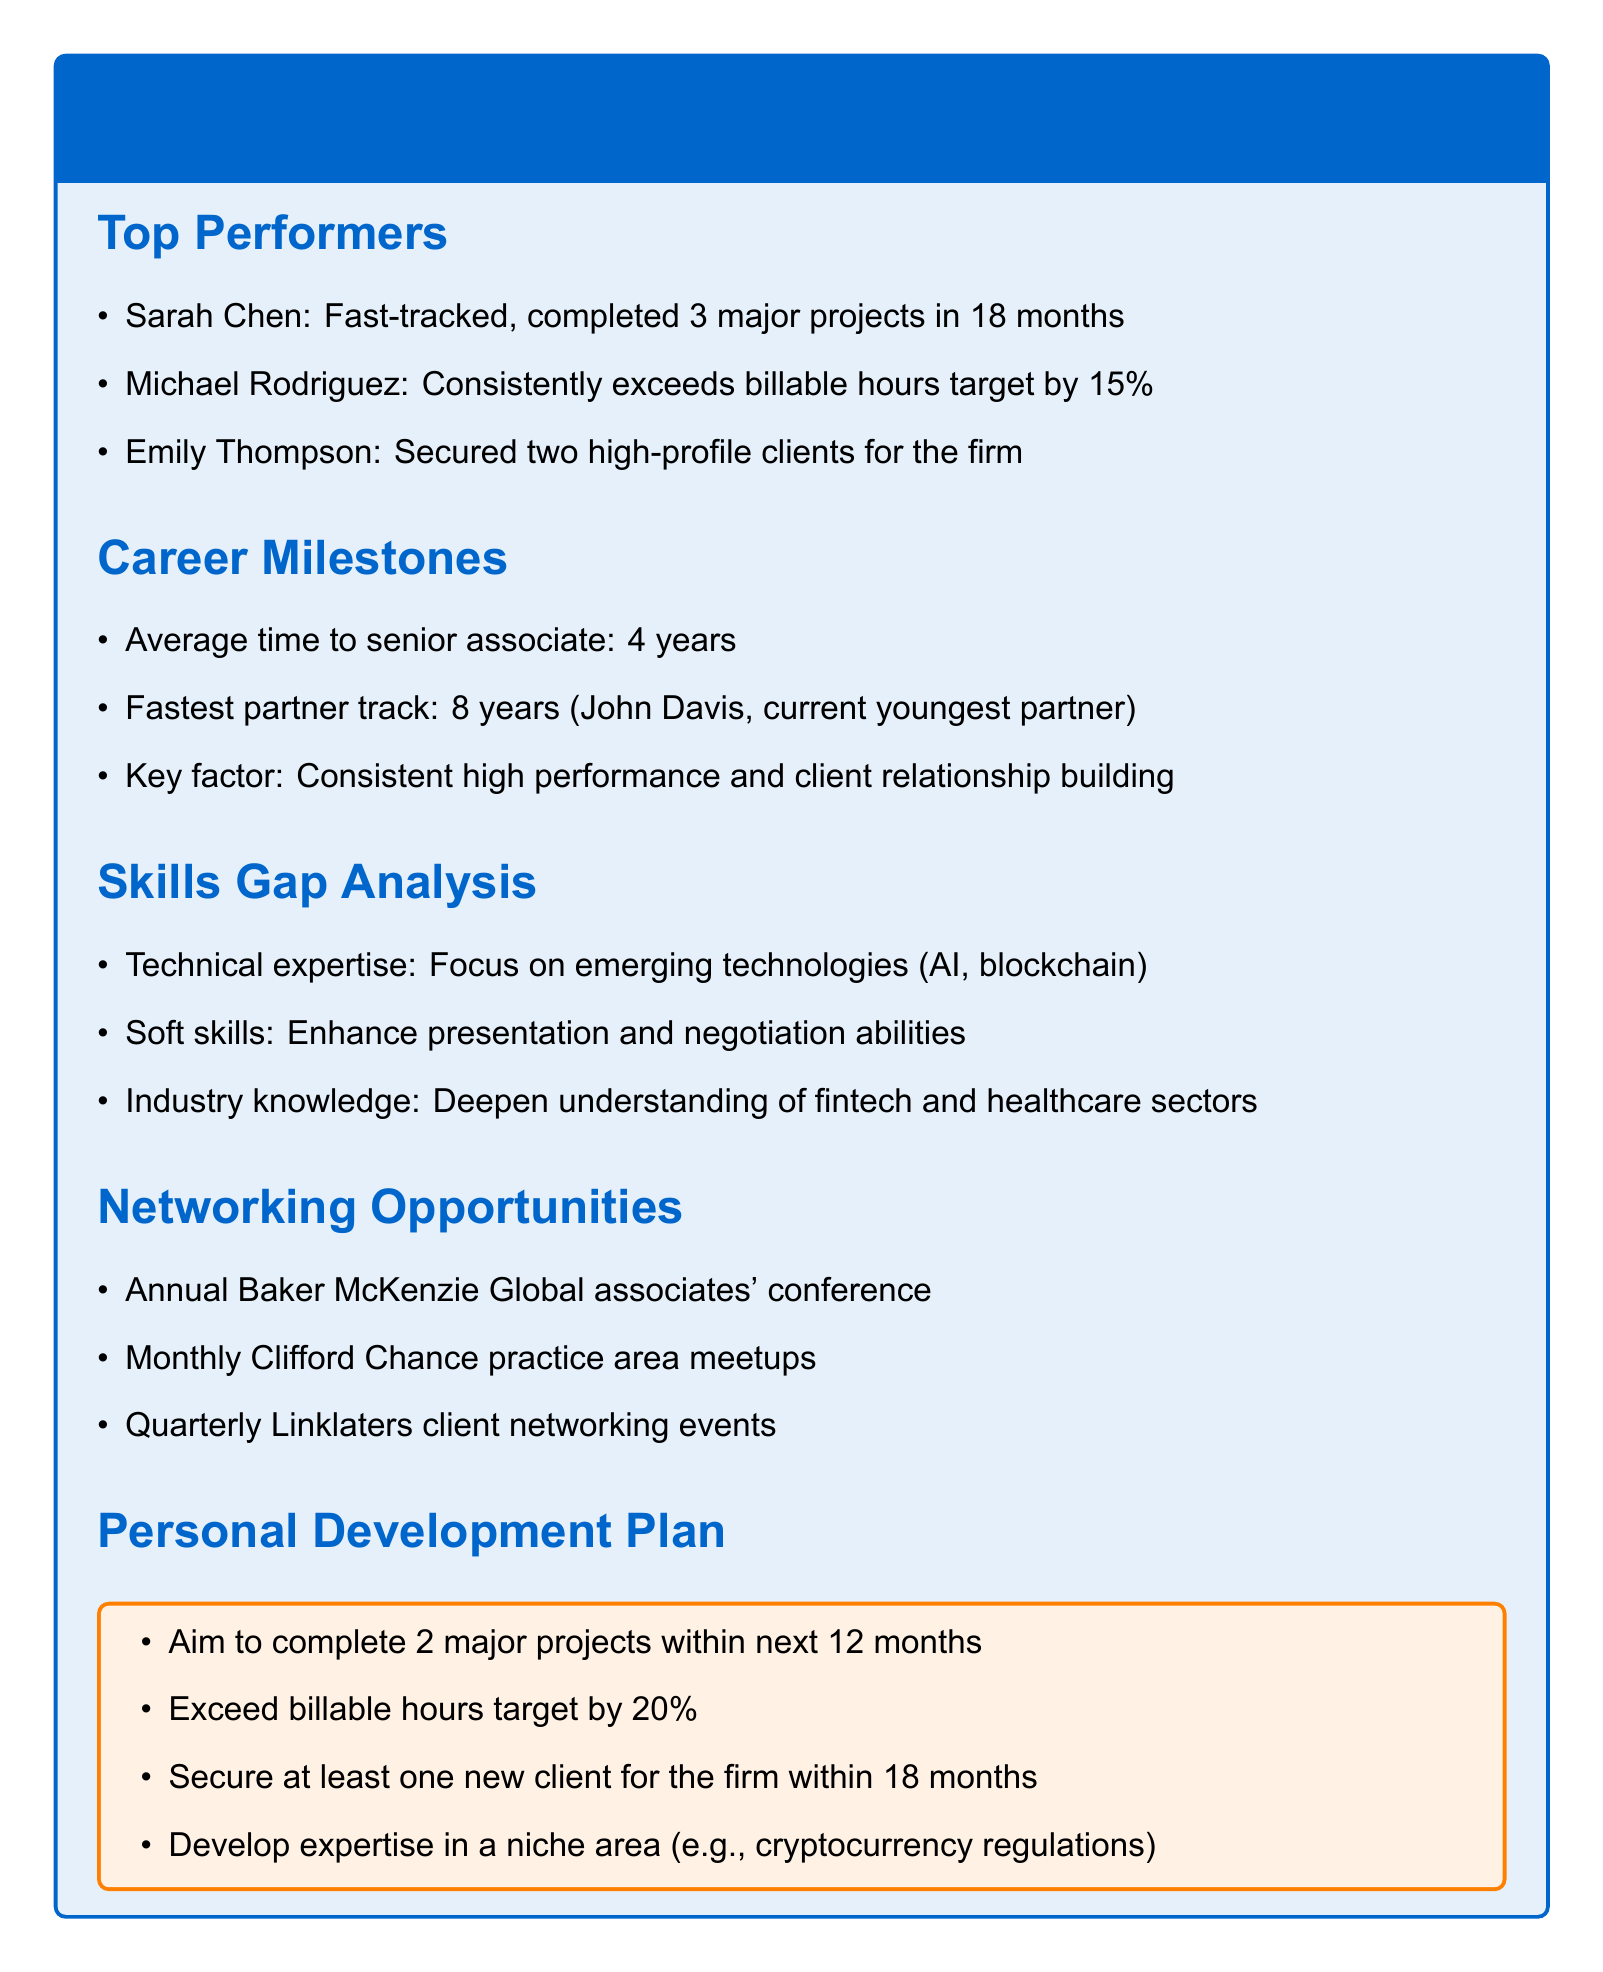What is the name of the fastest partner track? The fastest partner track is mentioned as being held by John Davis, who is currently the youngest partner.
Answer: John Davis How many major projects did Sarah Chen complete? Sarah Chen is noted to have completed 3 major projects in a span of 18 months.
Answer: 3 What is the average time to become a senior associate? The document states that the average time to senior associate is 4 years.
Answer: 4 years What percentage does Michael Rodriguez exceed billable hours target by? The document indicates that Michael Rodriguez exceeds his billable hours target by 15 percent.
Answer: 15% What is one key factor for career progression mentioned? The document points out that consistent high performance and client relationship building are key factors for career progression.
Answer: Consistent high performance and client relationship building Which networking event occurs quarterly? The quarterly event mentioned in the document is the Linklaters client networking events.
Answer: Linklaters client networking events What is one skill area to enhance according to the Skills Gap Analysis? The Skills Gap Analysis suggests enhancing presentation abilities.
Answer: Presentation abilities What is the aim for the number of major projects to complete in the next 12 months? The Personal Development Plan states an aim to complete 2 major projects within the next 12 months.
Answer: 2 major projects 